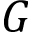<formula> <loc_0><loc_0><loc_500><loc_500>G</formula> 